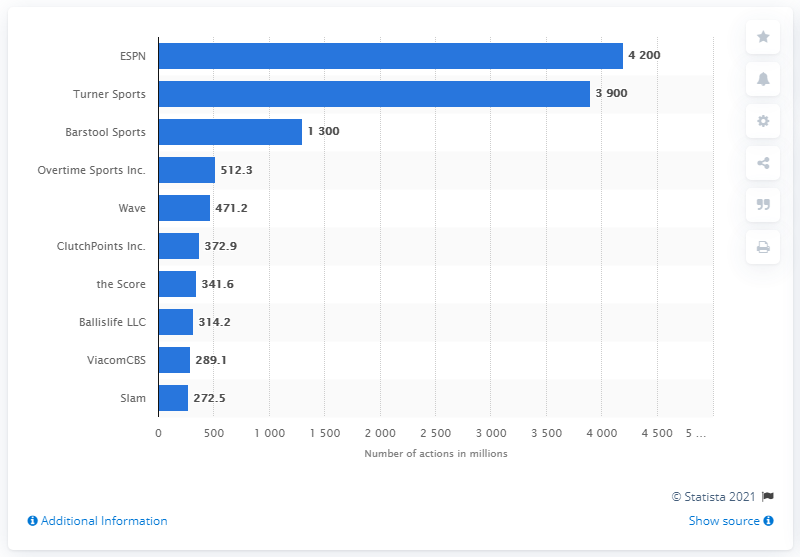Mention a couple of crucial points in this snapshot. In 2020, ESPN received approximately 4,200 social media actions. Turning Sports was the second most popular sports media company in the United States in 2020. In 2020, ESPN was the most popular sports media company in the United States. 